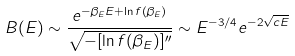Convert formula to latex. <formula><loc_0><loc_0><loc_500><loc_500>B ( E ) \sim \frac { e ^ { - \beta _ { E } E + \ln f ( \beta _ { E } ) } } { \sqrt { - [ \ln f ( \beta _ { E } ) ] ^ { \prime \prime } } } \sim E ^ { - 3 / 4 } e ^ { - 2 \sqrt { c E } }</formula> 